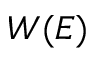<formula> <loc_0><loc_0><loc_500><loc_500>W ( E )</formula> 